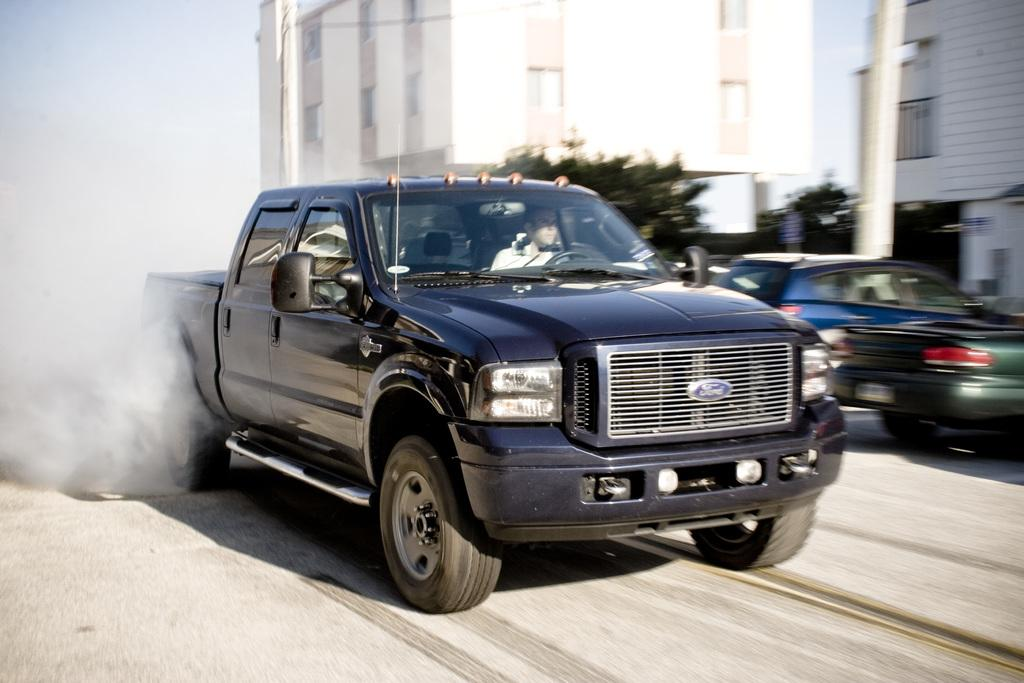What types of vehicles are in the image? The image contains vehicles, but the specific types are not mentioned. What can be seen in the background of the image? There are buildings, trees, poles, and other objects in the background of the image. What is at the bottom of the image? There is a road at the bottom of the image. What is the average income of the people living in the buildings in the image? The image does not provide information about the income of the people living in the buildings. What type of crime is being committed in the image? There is no indication of any crime being committed in the image. 